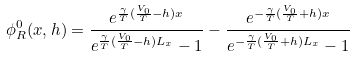<formula> <loc_0><loc_0><loc_500><loc_500>\phi ^ { 0 } _ { R } ( x , h ) = \frac { e ^ { \frac { \gamma } { T } ( \frac { V _ { 0 } } { T } - h ) x } } { e ^ { \frac { \gamma } { T } ( \frac { V _ { 0 } } { T } - h ) L _ { x } } - 1 } - \frac { e ^ { - \frac { \gamma } { T } ( \frac { V _ { 0 } } { T } + h ) x } } { e ^ { - \frac { \gamma } { T } ( \frac { V _ { 0 } } { T } + h ) L _ { x } } - 1 }</formula> 